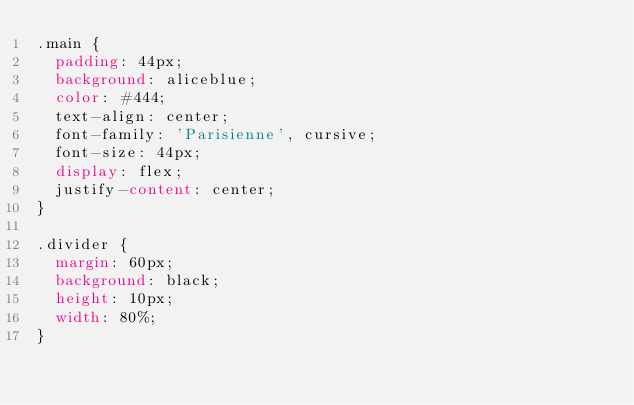Convert code to text. <code><loc_0><loc_0><loc_500><loc_500><_CSS_>.main {
  padding: 44px;
  background: aliceblue;
  color: #444;
  text-align: center;
  font-family: 'Parisienne', cursive;
  font-size: 44px;
  display: flex;
  justify-content: center;
}

.divider {
  margin: 60px;
  background: black;
  height: 10px;
  width: 80%;
}
</code> 